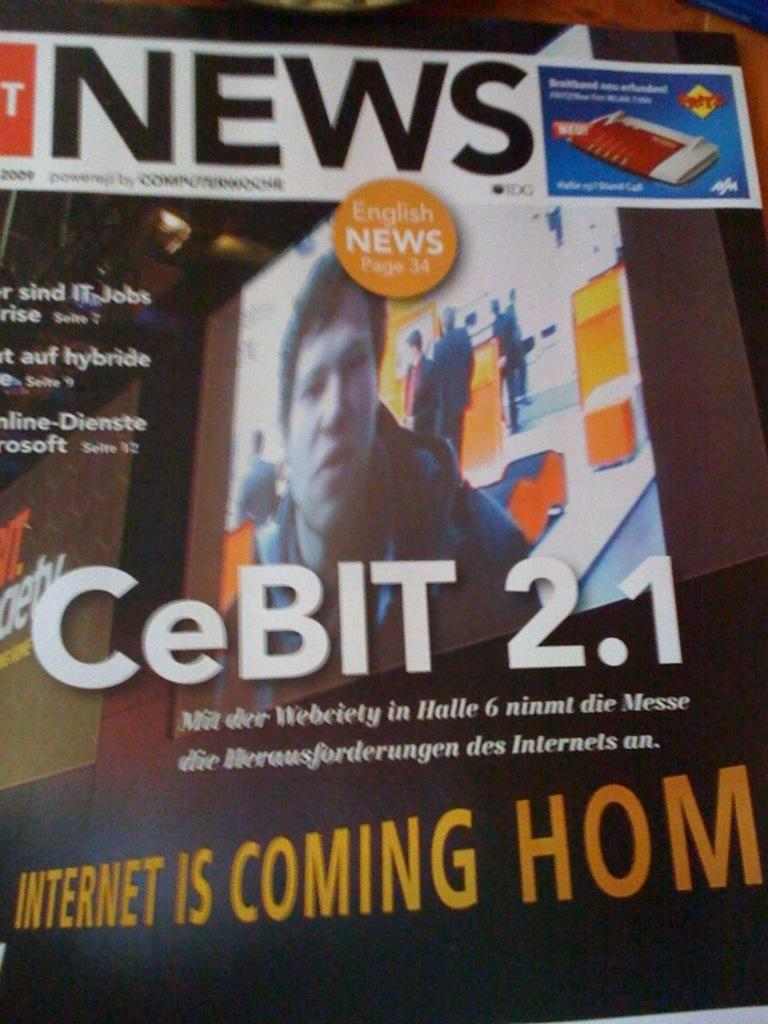Provide a one-sentence caption for the provided image. A book about CeBIT 2.1 that says internet is coming home. 